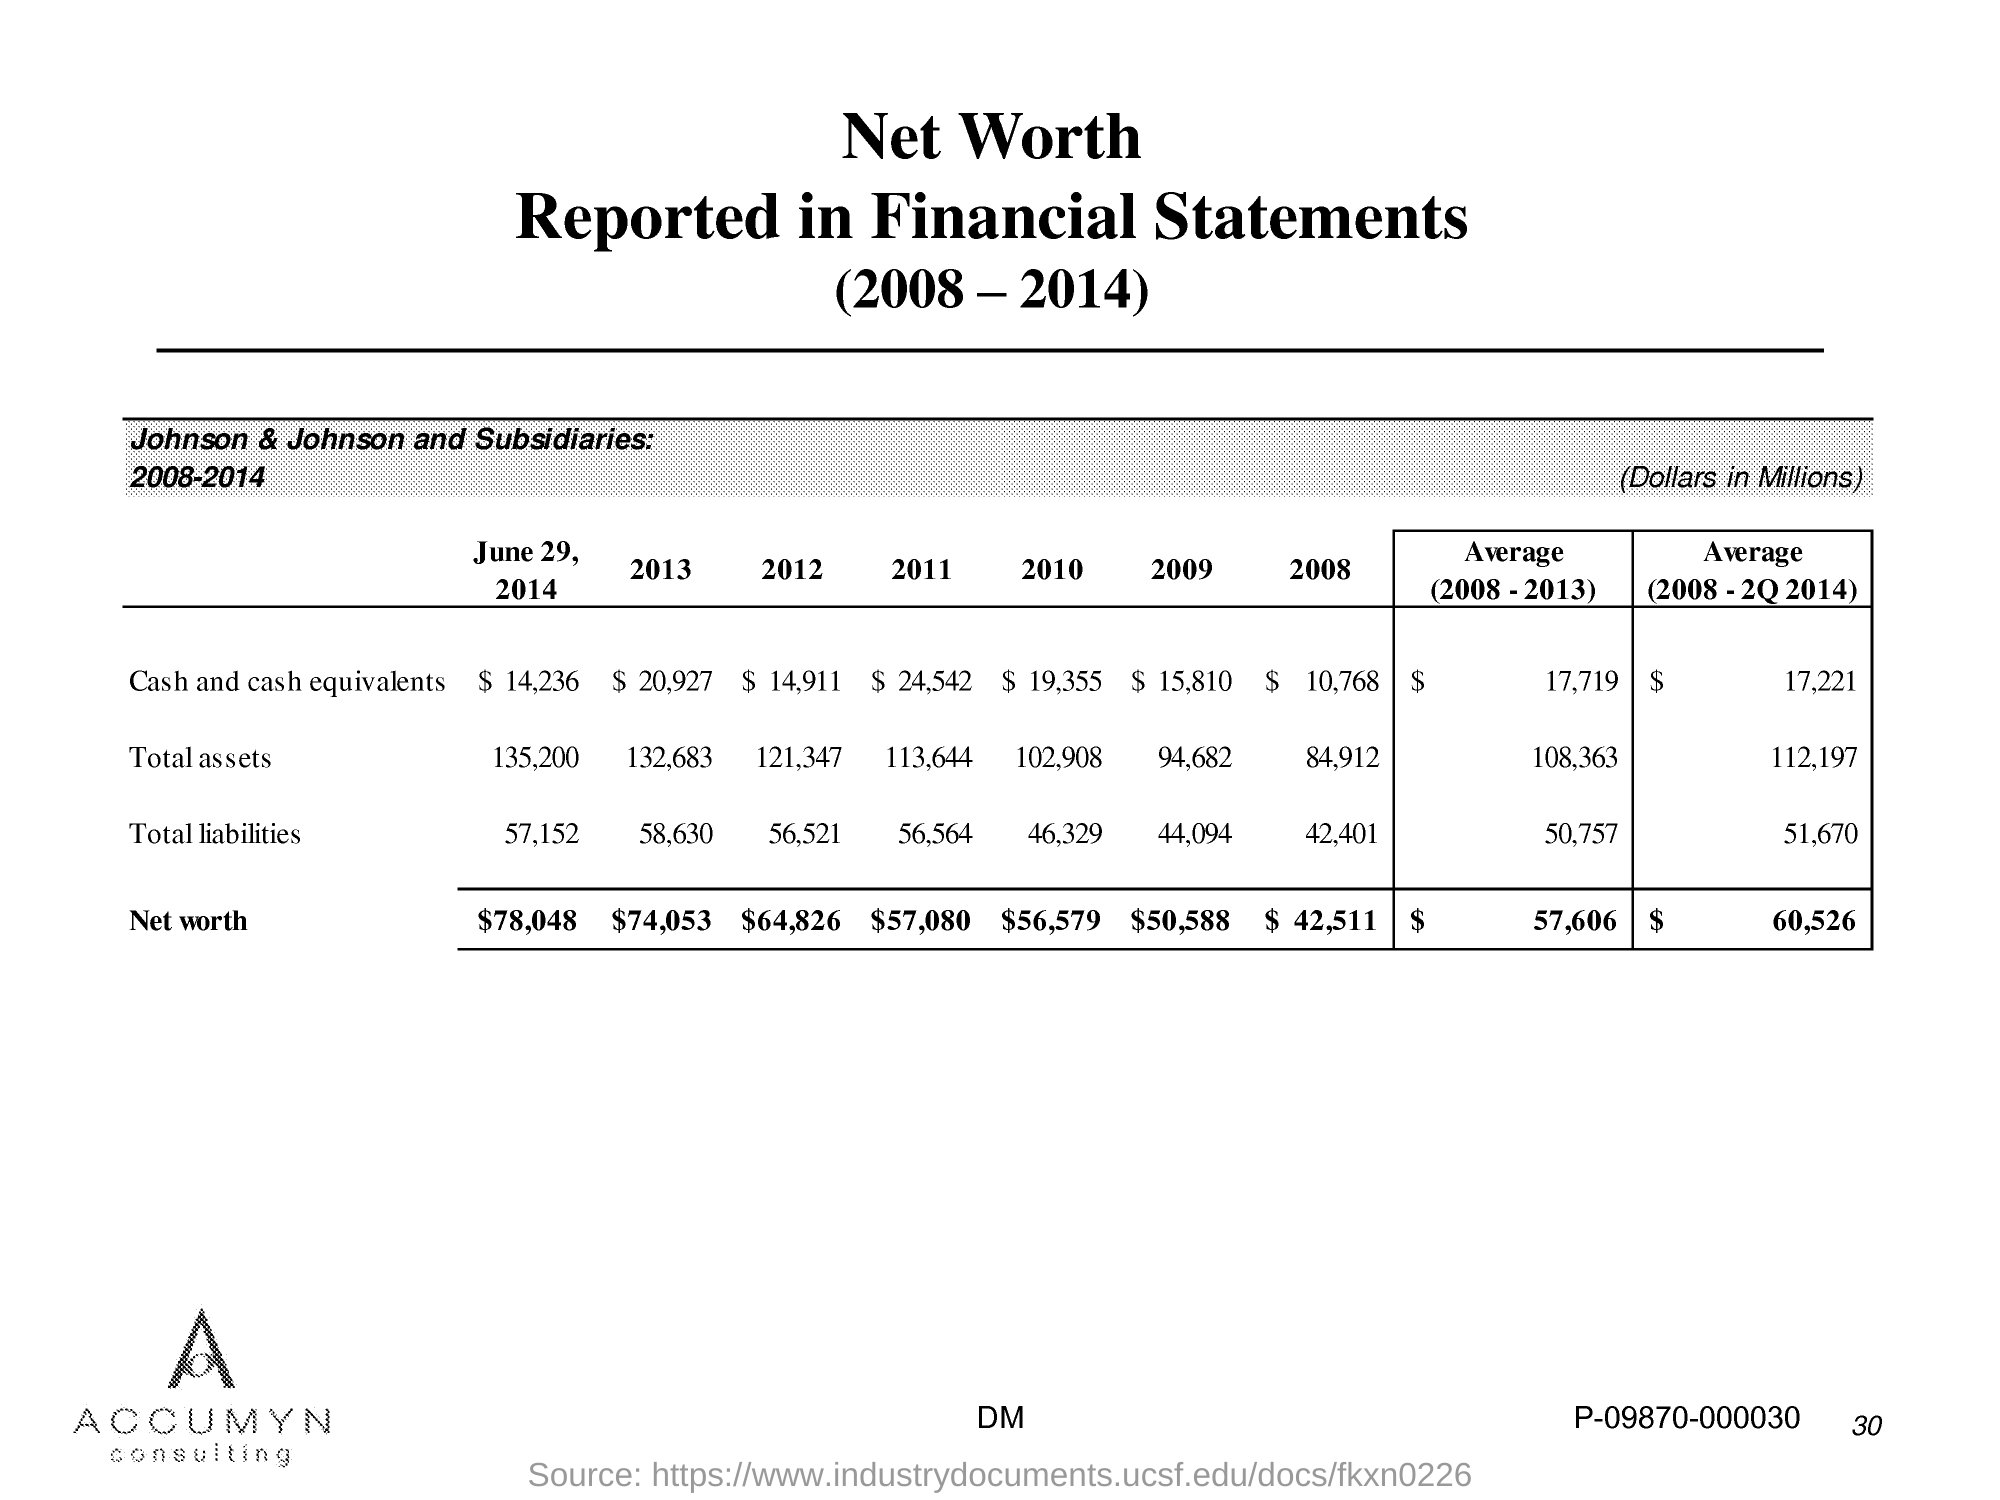Draw attention to some important aspects in this diagram. In 2009, the total assets were 94,682. In 2010, the total assets were 102,908. The total liabilities in 2011 were approximately 56,564. In 2011, the total assets were 113,644. The total liabilities in 2012 were 56,521. 